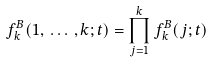Convert formula to latex. <formula><loc_0><loc_0><loc_500><loc_500>f ^ { B } _ { k } ( 1 , \, \dots \, , k ; t ) = \prod _ { j = 1 } ^ { k } f ^ { B } _ { k } ( j ; t )</formula> 